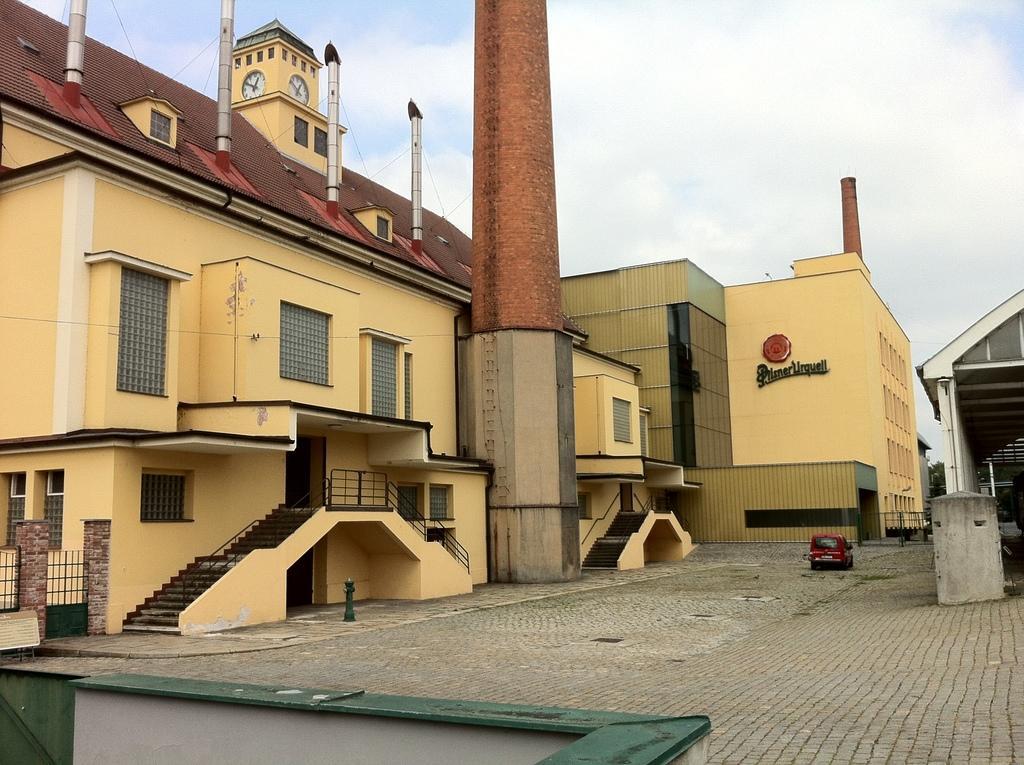Can you describe this image briefly? In this picture these buildings look like industries with chimneys on the rooftop. We can see a vehicle on the road. 